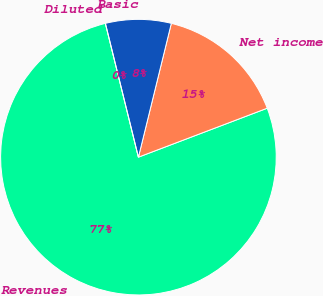Convert chart to OTSL. <chart><loc_0><loc_0><loc_500><loc_500><pie_chart><fcel>Revenues<fcel>Net income<fcel>Basic<fcel>Diluted<nl><fcel>76.92%<fcel>15.38%<fcel>7.69%<fcel>0.0%<nl></chart> 